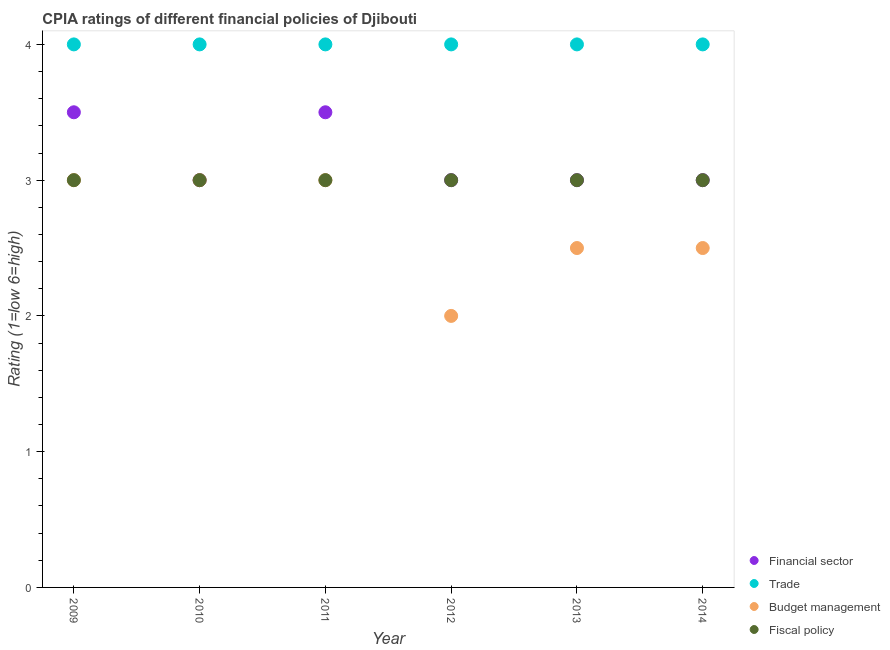How many different coloured dotlines are there?
Offer a terse response. 4. What is the cpia rating of trade in 2012?
Ensure brevity in your answer.  4. In which year was the cpia rating of trade maximum?
Keep it short and to the point. 2009. What is the difference between the cpia rating of trade in 2011 and that in 2013?
Your answer should be very brief. 0. What is the average cpia rating of financial sector per year?
Offer a very short reply. 3.17. In the year 2012, what is the difference between the cpia rating of budget management and cpia rating of trade?
Your answer should be compact. -2. What is the ratio of the cpia rating of budget management in 2011 to that in 2014?
Ensure brevity in your answer.  1.2. Is the cpia rating of fiscal policy in 2009 less than that in 2011?
Make the answer very short. No. What is the difference between the highest and the second highest cpia rating of fiscal policy?
Your answer should be compact. 0. In how many years, is the cpia rating of financial sector greater than the average cpia rating of financial sector taken over all years?
Your answer should be compact. 2. Is the sum of the cpia rating of trade in 2009 and 2013 greater than the maximum cpia rating of fiscal policy across all years?
Provide a succinct answer. Yes. Is the cpia rating of fiscal policy strictly greater than the cpia rating of financial sector over the years?
Keep it short and to the point. No. How many dotlines are there?
Offer a terse response. 4. What is the difference between two consecutive major ticks on the Y-axis?
Keep it short and to the point. 1. Are the values on the major ticks of Y-axis written in scientific E-notation?
Your answer should be very brief. No. Does the graph contain grids?
Offer a terse response. No. Where does the legend appear in the graph?
Offer a terse response. Bottom right. How many legend labels are there?
Ensure brevity in your answer.  4. What is the title of the graph?
Ensure brevity in your answer.  CPIA ratings of different financial policies of Djibouti. What is the label or title of the Y-axis?
Provide a succinct answer. Rating (1=low 6=high). What is the Rating (1=low 6=high) in Budget management in 2009?
Ensure brevity in your answer.  3. What is the Rating (1=low 6=high) in Trade in 2010?
Ensure brevity in your answer.  4. What is the Rating (1=low 6=high) of Budget management in 2010?
Ensure brevity in your answer.  3. What is the Rating (1=low 6=high) of Fiscal policy in 2010?
Your response must be concise. 3. What is the Rating (1=low 6=high) of Financial sector in 2011?
Give a very brief answer. 3.5. What is the Rating (1=low 6=high) in Budget management in 2011?
Keep it short and to the point. 3. What is the Rating (1=low 6=high) in Fiscal policy in 2011?
Provide a short and direct response. 3. What is the Rating (1=low 6=high) of Trade in 2012?
Provide a succinct answer. 4. What is the Rating (1=low 6=high) in Budget management in 2012?
Provide a short and direct response. 2. What is the Rating (1=low 6=high) of Fiscal policy in 2012?
Keep it short and to the point. 3. What is the Rating (1=low 6=high) of Trade in 2014?
Make the answer very short. 4. What is the Rating (1=low 6=high) in Budget management in 2014?
Keep it short and to the point. 2.5. Across all years, what is the maximum Rating (1=low 6=high) of Financial sector?
Provide a short and direct response. 3.5. Across all years, what is the maximum Rating (1=low 6=high) of Budget management?
Your answer should be compact. 3. Across all years, what is the maximum Rating (1=low 6=high) in Fiscal policy?
Offer a very short reply. 3. Across all years, what is the minimum Rating (1=low 6=high) of Financial sector?
Offer a terse response. 3. Across all years, what is the minimum Rating (1=low 6=high) in Trade?
Offer a terse response. 4. Across all years, what is the minimum Rating (1=low 6=high) in Fiscal policy?
Your response must be concise. 3. What is the total Rating (1=low 6=high) in Trade in the graph?
Make the answer very short. 24. What is the total Rating (1=low 6=high) of Budget management in the graph?
Offer a very short reply. 16. What is the difference between the Rating (1=low 6=high) in Financial sector in 2009 and that in 2010?
Your response must be concise. 0.5. What is the difference between the Rating (1=low 6=high) of Trade in 2009 and that in 2010?
Give a very brief answer. 0. What is the difference between the Rating (1=low 6=high) in Budget management in 2009 and that in 2010?
Keep it short and to the point. 0. What is the difference between the Rating (1=low 6=high) in Financial sector in 2009 and that in 2011?
Ensure brevity in your answer.  0. What is the difference between the Rating (1=low 6=high) in Trade in 2009 and that in 2011?
Make the answer very short. 0. What is the difference between the Rating (1=low 6=high) of Budget management in 2009 and that in 2011?
Your answer should be very brief. 0. What is the difference between the Rating (1=low 6=high) of Trade in 2009 and that in 2012?
Provide a short and direct response. 0. What is the difference between the Rating (1=low 6=high) in Budget management in 2009 and that in 2012?
Your answer should be compact. 1. What is the difference between the Rating (1=low 6=high) of Financial sector in 2009 and that in 2013?
Your response must be concise. 0.5. What is the difference between the Rating (1=low 6=high) in Budget management in 2009 and that in 2013?
Your response must be concise. 0.5. What is the difference between the Rating (1=low 6=high) in Fiscal policy in 2009 and that in 2013?
Offer a terse response. 0. What is the difference between the Rating (1=low 6=high) of Budget management in 2009 and that in 2014?
Your response must be concise. 0.5. What is the difference between the Rating (1=low 6=high) in Fiscal policy in 2009 and that in 2014?
Your response must be concise. 0. What is the difference between the Rating (1=low 6=high) in Financial sector in 2010 and that in 2011?
Your response must be concise. -0.5. What is the difference between the Rating (1=low 6=high) of Trade in 2010 and that in 2011?
Your answer should be compact. 0. What is the difference between the Rating (1=low 6=high) in Financial sector in 2010 and that in 2012?
Your answer should be very brief. 0. What is the difference between the Rating (1=low 6=high) in Fiscal policy in 2010 and that in 2012?
Offer a very short reply. 0. What is the difference between the Rating (1=low 6=high) in Financial sector in 2010 and that in 2013?
Your response must be concise. 0. What is the difference between the Rating (1=low 6=high) in Trade in 2010 and that in 2013?
Offer a very short reply. 0. What is the difference between the Rating (1=low 6=high) of Fiscal policy in 2010 and that in 2013?
Provide a short and direct response. 0. What is the difference between the Rating (1=low 6=high) in Fiscal policy in 2010 and that in 2014?
Your answer should be very brief. 0. What is the difference between the Rating (1=low 6=high) of Budget management in 2011 and that in 2012?
Your answer should be compact. 1. What is the difference between the Rating (1=low 6=high) in Financial sector in 2011 and that in 2013?
Your response must be concise. 0.5. What is the difference between the Rating (1=low 6=high) of Trade in 2011 and that in 2013?
Provide a short and direct response. 0. What is the difference between the Rating (1=low 6=high) in Financial sector in 2011 and that in 2014?
Provide a succinct answer. 0.5. What is the difference between the Rating (1=low 6=high) in Budget management in 2011 and that in 2014?
Offer a very short reply. 0.5. What is the difference between the Rating (1=low 6=high) in Financial sector in 2012 and that in 2013?
Make the answer very short. 0. What is the difference between the Rating (1=low 6=high) in Trade in 2012 and that in 2013?
Your response must be concise. 0. What is the difference between the Rating (1=low 6=high) of Budget management in 2012 and that in 2014?
Provide a succinct answer. -0.5. What is the difference between the Rating (1=low 6=high) in Fiscal policy in 2012 and that in 2014?
Provide a succinct answer. 0. What is the difference between the Rating (1=low 6=high) in Trade in 2013 and that in 2014?
Provide a succinct answer. 0. What is the difference between the Rating (1=low 6=high) in Budget management in 2013 and that in 2014?
Ensure brevity in your answer.  0. What is the difference between the Rating (1=low 6=high) of Fiscal policy in 2013 and that in 2014?
Ensure brevity in your answer.  0. What is the difference between the Rating (1=low 6=high) of Financial sector in 2009 and the Rating (1=low 6=high) of Trade in 2010?
Your response must be concise. -0.5. What is the difference between the Rating (1=low 6=high) of Financial sector in 2009 and the Rating (1=low 6=high) of Budget management in 2010?
Make the answer very short. 0.5. What is the difference between the Rating (1=low 6=high) of Trade in 2009 and the Rating (1=low 6=high) of Budget management in 2010?
Offer a very short reply. 1. What is the difference between the Rating (1=low 6=high) of Trade in 2009 and the Rating (1=low 6=high) of Fiscal policy in 2010?
Ensure brevity in your answer.  1. What is the difference between the Rating (1=low 6=high) in Budget management in 2009 and the Rating (1=low 6=high) in Fiscal policy in 2010?
Provide a succinct answer. 0. What is the difference between the Rating (1=low 6=high) in Financial sector in 2009 and the Rating (1=low 6=high) in Trade in 2011?
Offer a very short reply. -0.5. What is the difference between the Rating (1=low 6=high) in Financial sector in 2009 and the Rating (1=low 6=high) in Budget management in 2011?
Provide a succinct answer. 0.5. What is the difference between the Rating (1=low 6=high) in Trade in 2009 and the Rating (1=low 6=high) in Fiscal policy in 2011?
Give a very brief answer. 1. What is the difference between the Rating (1=low 6=high) in Trade in 2009 and the Rating (1=low 6=high) in Budget management in 2012?
Your answer should be very brief. 2. What is the difference between the Rating (1=low 6=high) of Trade in 2009 and the Rating (1=low 6=high) of Fiscal policy in 2012?
Provide a short and direct response. 1. What is the difference between the Rating (1=low 6=high) of Financial sector in 2009 and the Rating (1=low 6=high) of Trade in 2013?
Provide a succinct answer. -0.5. What is the difference between the Rating (1=low 6=high) in Trade in 2009 and the Rating (1=low 6=high) in Budget management in 2013?
Your answer should be very brief. 1.5. What is the difference between the Rating (1=low 6=high) in Budget management in 2009 and the Rating (1=low 6=high) in Fiscal policy in 2013?
Provide a succinct answer. 0. What is the difference between the Rating (1=low 6=high) of Financial sector in 2009 and the Rating (1=low 6=high) of Trade in 2014?
Your answer should be very brief. -0.5. What is the difference between the Rating (1=low 6=high) of Financial sector in 2009 and the Rating (1=low 6=high) of Budget management in 2014?
Give a very brief answer. 1. What is the difference between the Rating (1=low 6=high) of Financial sector in 2009 and the Rating (1=low 6=high) of Fiscal policy in 2014?
Your response must be concise. 0.5. What is the difference between the Rating (1=low 6=high) of Financial sector in 2010 and the Rating (1=low 6=high) of Budget management in 2011?
Your answer should be very brief. 0. What is the difference between the Rating (1=low 6=high) of Trade in 2010 and the Rating (1=low 6=high) of Budget management in 2011?
Ensure brevity in your answer.  1. What is the difference between the Rating (1=low 6=high) of Trade in 2010 and the Rating (1=low 6=high) of Fiscal policy in 2011?
Offer a very short reply. 1. What is the difference between the Rating (1=low 6=high) of Financial sector in 2010 and the Rating (1=low 6=high) of Fiscal policy in 2012?
Your answer should be compact. 0. What is the difference between the Rating (1=low 6=high) in Trade in 2010 and the Rating (1=low 6=high) in Budget management in 2012?
Your response must be concise. 2. What is the difference between the Rating (1=low 6=high) of Financial sector in 2010 and the Rating (1=low 6=high) of Budget management in 2013?
Keep it short and to the point. 0.5. What is the difference between the Rating (1=low 6=high) of Trade in 2010 and the Rating (1=low 6=high) of Fiscal policy in 2013?
Provide a succinct answer. 1. What is the difference between the Rating (1=low 6=high) of Budget management in 2010 and the Rating (1=low 6=high) of Fiscal policy in 2013?
Give a very brief answer. 0. What is the difference between the Rating (1=low 6=high) of Financial sector in 2010 and the Rating (1=low 6=high) of Trade in 2014?
Provide a short and direct response. -1. What is the difference between the Rating (1=low 6=high) of Financial sector in 2010 and the Rating (1=low 6=high) of Budget management in 2014?
Provide a short and direct response. 0.5. What is the difference between the Rating (1=low 6=high) in Trade in 2010 and the Rating (1=low 6=high) in Budget management in 2014?
Provide a short and direct response. 1.5. What is the difference between the Rating (1=low 6=high) of Budget management in 2010 and the Rating (1=low 6=high) of Fiscal policy in 2014?
Give a very brief answer. 0. What is the difference between the Rating (1=low 6=high) in Financial sector in 2011 and the Rating (1=low 6=high) in Budget management in 2012?
Provide a succinct answer. 1.5. What is the difference between the Rating (1=low 6=high) of Trade in 2011 and the Rating (1=low 6=high) of Budget management in 2012?
Offer a terse response. 2. What is the difference between the Rating (1=low 6=high) in Trade in 2011 and the Rating (1=low 6=high) in Fiscal policy in 2012?
Offer a terse response. 1. What is the difference between the Rating (1=low 6=high) of Budget management in 2011 and the Rating (1=low 6=high) of Fiscal policy in 2012?
Offer a very short reply. 0. What is the difference between the Rating (1=low 6=high) in Financial sector in 2011 and the Rating (1=low 6=high) in Fiscal policy in 2013?
Provide a short and direct response. 0.5. What is the difference between the Rating (1=low 6=high) of Budget management in 2011 and the Rating (1=low 6=high) of Fiscal policy in 2013?
Ensure brevity in your answer.  0. What is the difference between the Rating (1=low 6=high) in Financial sector in 2011 and the Rating (1=low 6=high) in Trade in 2014?
Provide a succinct answer. -0.5. What is the difference between the Rating (1=low 6=high) of Financial sector in 2011 and the Rating (1=low 6=high) of Fiscal policy in 2014?
Provide a short and direct response. 0.5. What is the difference between the Rating (1=low 6=high) in Financial sector in 2012 and the Rating (1=low 6=high) in Trade in 2013?
Your answer should be very brief. -1. What is the difference between the Rating (1=low 6=high) in Trade in 2012 and the Rating (1=low 6=high) in Budget management in 2013?
Your answer should be very brief. 1.5. What is the difference between the Rating (1=low 6=high) in Trade in 2012 and the Rating (1=low 6=high) in Fiscal policy in 2013?
Give a very brief answer. 1. What is the difference between the Rating (1=low 6=high) in Financial sector in 2012 and the Rating (1=low 6=high) in Trade in 2014?
Give a very brief answer. -1. What is the difference between the Rating (1=low 6=high) in Trade in 2012 and the Rating (1=low 6=high) in Fiscal policy in 2014?
Provide a succinct answer. 1. What is the difference between the Rating (1=low 6=high) in Budget management in 2012 and the Rating (1=low 6=high) in Fiscal policy in 2014?
Offer a terse response. -1. What is the difference between the Rating (1=low 6=high) in Financial sector in 2013 and the Rating (1=low 6=high) in Fiscal policy in 2014?
Ensure brevity in your answer.  0. What is the average Rating (1=low 6=high) in Financial sector per year?
Give a very brief answer. 3.17. What is the average Rating (1=low 6=high) in Budget management per year?
Provide a short and direct response. 2.67. In the year 2009, what is the difference between the Rating (1=low 6=high) of Financial sector and Rating (1=low 6=high) of Trade?
Give a very brief answer. -0.5. In the year 2009, what is the difference between the Rating (1=low 6=high) of Financial sector and Rating (1=low 6=high) of Budget management?
Offer a terse response. 0.5. In the year 2009, what is the difference between the Rating (1=low 6=high) of Trade and Rating (1=low 6=high) of Budget management?
Provide a short and direct response. 1. In the year 2010, what is the difference between the Rating (1=low 6=high) in Trade and Rating (1=low 6=high) in Budget management?
Offer a very short reply. 1. In the year 2010, what is the difference between the Rating (1=low 6=high) in Trade and Rating (1=low 6=high) in Fiscal policy?
Ensure brevity in your answer.  1. In the year 2010, what is the difference between the Rating (1=low 6=high) of Budget management and Rating (1=low 6=high) of Fiscal policy?
Keep it short and to the point. 0. In the year 2011, what is the difference between the Rating (1=low 6=high) of Financial sector and Rating (1=low 6=high) of Budget management?
Your answer should be compact. 0.5. In the year 2011, what is the difference between the Rating (1=low 6=high) in Trade and Rating (1=low 6=high) in Budget management?
Provide a short and direct response. 1. In the year 2011, what is the difference between the Rating (1=low 6=high) of Trade and Rating (1=low 6=high) of Fiscal policy?
Give a very brief answer. 1. In the year 2012, what is the difference between the Rating (1=low 6=high) of Financial sector and Rating (1=low 6=high) of Trade?
Ensure brevity in your answer.  -1. In the year 2012, what is the difference between the Rating (1=low 6=high) of Financial sector and Rating (1=low 6=high) of Budget management?
Give a very brief answer. 1. In the year 2012, what is the difference between the Rating (1=low 6=high) in Financial sector and Rating (1=low 6=high) in Fiscal policy?
Your answer should be very brief. 0. In the year 2012, what is the difference between the Rating (1=low 6=high) in Trade and Rating (1=low 6=high) in Budget management?
Provide a succinct answer. 2. In the year 2012, what is the difference between the Rating (1=low 6=high) in Budget management and Rating (1=low 6=high) in Fiscal policy?
Give a very brief answer. -1. In the year 2013, what is the difference between the Rating (1=low 6=high) in Financial sector and Rating (1=low 6=high) in Trade?
Provide a succinct answer. -1. In the year 2013, what is the difference between the Rating (1=low 6=high) of Trade and Rating (1=low 6=high) of Budget management?
Your answer should be compact. 1.5. In the year 2013, what is the difference between the Rating (1=low 6=high) of Trade and Rating (1=low 6=high) of Fiscal policy?
Your answer should be compact. 1. In the year 2014, what is the difference between the Rating (1=low 6=high) in Financial sector and Rating (1=low 6=high) in Budget management?
Provide a short and direct response. 0.5. In the year 2014, what is the difference between the Rating (1=low 6=high) of Financial sector and Rating (1=low 6=high) of Fiscal policy?
Ensure brevity in your answer.  0. What is the ratio of the Rating (1=low 6=high) in Financial sector in 2009 to that in 2010?
Provide a short and direct response. 1.17. What is the ratio of the Rating (1=low 6=high) of Fiscal policy in 2009 to that in 2010?
Offer a terse response. 1. What is the ratio of the Rating (1=low 6=high) in Financial sector in 2009 to that in 2011?
Ensure brevity in your answer.  1. What is the ratio of the Rating (1=low 6=high) in Budget management in 2009 to that in 2011?
Offer a terse response. 1. What is the ratio of the Rating (1=low 6=high) of Financial sector in 2009 to that in 2012?
Offer a terse response. 1.17. What is the ratio of the Rating (1=low 6=high) in Financial sector in 2009 to that in 2013?
Provide a succinct answer. 1.17. What is the ratio of the Rating (1=low 6=high) in Budget management in 2009 to that in 2013?
Offer a very short reply. 1.2. What is the ratio of the Rating (1=low 6=high) of Trade in 2009 to that in 2014?
Offer a very short reply. 1. What is the ratio of the Rating (1=low 6=high) in Fiscal policy in 2009 to that in 2014?
Offer a terse response. 1. What is the ratio of the Rating (1=low 6=high) of Fiscal policy in 2010 to that in 2011?
Provide a short and direct response. 1. What is the ratio of the Rating (1=low 6=high) in Budget management in 2010 to that in 2012?
Give a very brief answer. 1.5. What is the ratio of the Rating (1=low 6=high) in Financial sector in 2010 to that in 2013?
Your response must be concise. 1. What is the ratio of the Rating (1=low 6=high) in Trade in 2010 to that in 2013?
Your answer should be very brief. 1. What is the ratio of the Rating (1=low 6=high) in Fiscal policy in 2010 to that in 2013?
Provide a short and direct response. 1. What is the ratio of the Rating (1=low 6=high) of Financial sector in 2010 to that in 2014?
Offer a very short reply. 1. What is the ratio of the Rating (1=low 6=high) of Trade in 2010 to that in 2014?
Offer a terse response. 1. What is the ratio of the Rating (1=low 6=high) of Fiscal policy in 2010 to that in 2014?
Keep it short and to the point. 1. What is the ratio of the Rating (1=low 6=high) of Financial sector in 2011 to that in 2012?
Your answer should be very brief. 1.17. What is the ratio of the Rating (1=low 6=high) of Trade in 2011 to that in 2012?
Offer a terse response. 1. What is the ratio of the Rating (1=low 6=high) in Fiscal policy in 2011 to that in 2012?
Your answer should be very brief. 1. What is the ratio of the Rating (1=low 6=high) of Trade in 2011 to that in 2013?
Your answer should be compact. 1. What is the ratio of the Rating (1=low 6=high) of Trade in 2011 to that in 2014?
Your response must be concise. 1. What is the ratio of the Rating (1=low 6=high) in Budget management in 2011 to that in 2014?
Your answer should be compact. 1.2. What is the ratio of the Rating (1=low 6=high) in Fiscal policy in 2011 to that in 2014?
Your response must be concise. 1. What is the ratio of the Rating (1=low 6=high) in Financial sector in 2012 to that in 2013?
Make the answer very short. 1. What is the ratio of the Rating (1=low 6=high) in Budget management in 2012 to that in 2013?
Your response must be concise. 0.8. What is the ratio of the Rating (1=low 6=high) in Financial sector in 2013 to that in 2014?
Ensure brevity in your answer.  1. What is the ratio of the Rating (1=low 6=high) of Trade in 2013 to that in 2014?
Your answer should be very brief. 1. What is the ratio of the Rating (1=low 6=high) in Budget management in 2013 to that in 2014?
Your answer should be compact. 1. What is the ratio of the Rating (1=low 6=high) in Fiscal policy in 2013 to that in 2014?
Make the answer very short. 1. What is the difference between the highest and the lowest Rating (1=low 6=high) in Budget management?
Offer a very short reply. 1. What is the difference between the highest and the lowest Rating (1=low 6=high) of Fiscal policy?
Make the answer very short. 0. 